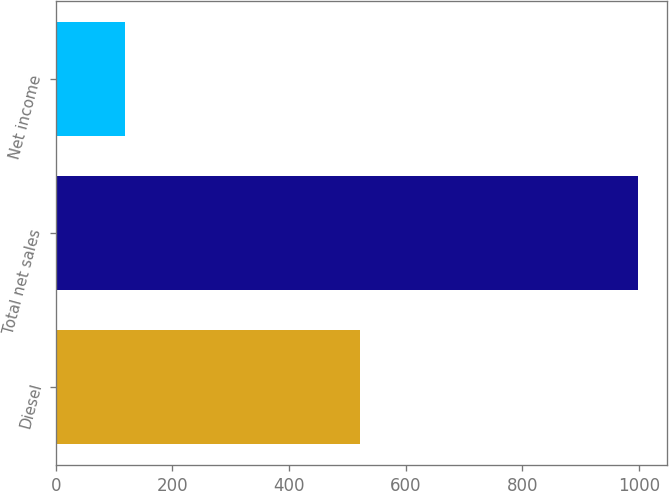<chart> <loc_0><loc_0><loc_500><loc_500><bar_chart><fcel>Diesel<fcel>Total net sales<fcel>Net income<nl><fcel>522<fcel>998<fcel>119<nl></chart> 